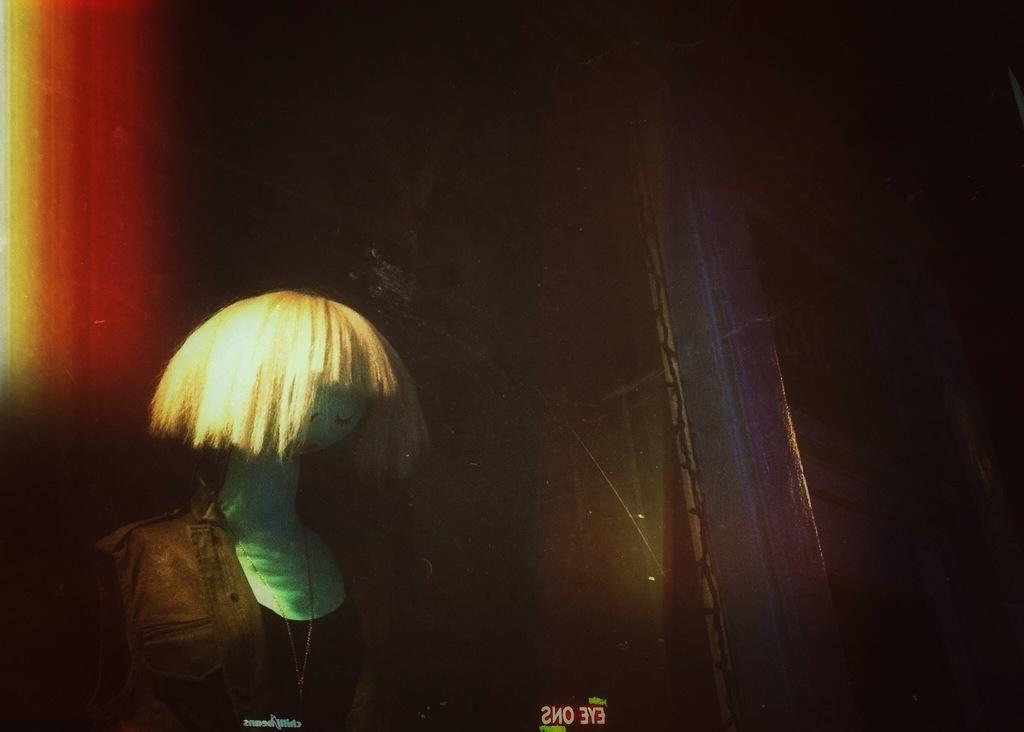What is the main subject of the image? There is a mannequin in the image. What is the mannequin wearing? The mannequin is wearing a dress. Can you describe the colors of the dress? The dress is in brown and black colors. What is the color of the background in the image? The background of the image is dark. What type of haircut does the mannequin have in the image? There is no hair visible on the mannequin in the image, as it is a mannequin and not a person. 